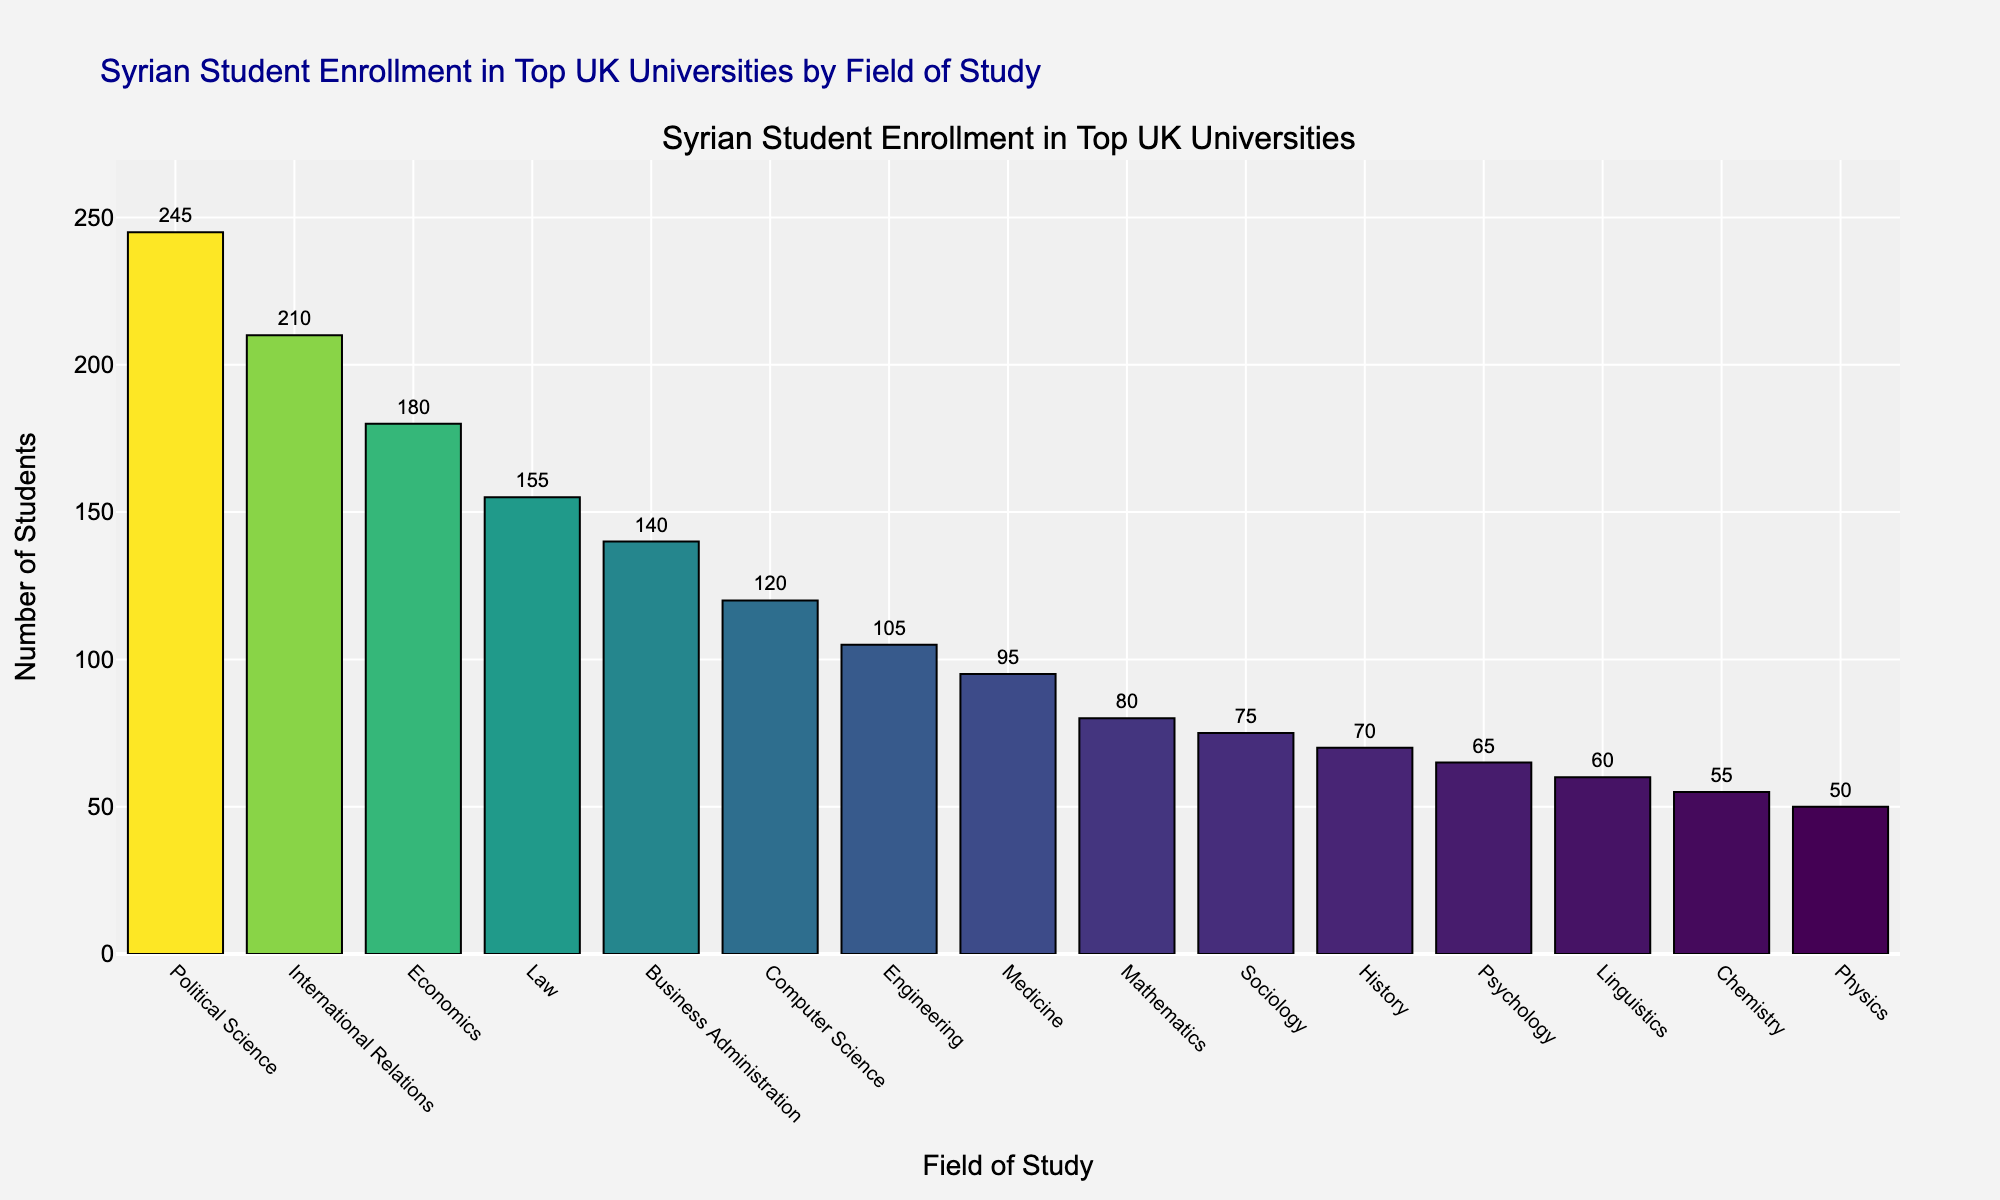Which field has the highest number of Syrian students enrolled in top UK universities? The highest bar corresponds to Political Science, indicating it has the highest number of students.
Answer: Political Science Which field has more Syrian students, Law or Engineering? Law has 155 students, whereas Engineering has 105 students according to the bar heights.
Answer: Law What is the difference in the number of students enrolled in Political Science and Medicine? Political Science has 245 students and Medicine has 95 students. The difference is 245 - 95.
Answer: 150 What is the total number of students enrolled in Political Science, International Relations, and Economics? Sum of students in Political Science (245), International Relations (210), and Economics (180) is 245 + 210 + 180.
Answer: 635 How many more students are enrolled in Political Science than in Sociology? Political Science has 245 students and Sociology has 75 students. The difference is 245 - 75.
Answer: 170 Which field has fewer students, Psychology or Linguistics? Psychology has 65 students and Linguistics has 60 students.
Answer: Linguistics What is the sum of students enrolled in Business Administration and Computer Science? Business Administration has 140 students, and Computer Science has 120. The sum is 140 + 120.
Answer: 260 Which fields have fewer than 100 students enrolled? Fields with bars shorter than the height representing 100 students are Medicine, Mathematics, Sociology, History, Psychology, Linguistics, Chemistry, and Physics.
Answer: Medicine, Mathematics, Sociology, History, Psychology, Linguistics, Chemistry, Physics What is the average number of students enrolled in the top three fields? The top three fields are Political Science (245), International Relations (210), and Economics (180). The average is (245 + 210 + 180) / 3.
Answer: 211.67 How much higher is the number of students in Economics compared to Chemistry? Economics has 180 students, while Chemistry has 55. The difference is 180 - 55.
Answer: 125 